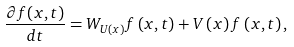Convert formula to latex. <formula><loc_0><loc_0><loc_500><loc_500>\frac { \partial f ( x , t ) } { d t } = W _ { U \left ( x \right ) } f \left ( x , t \right ) + V \left ( x \right ) f \left ( x , t \right ) ,</formula> 